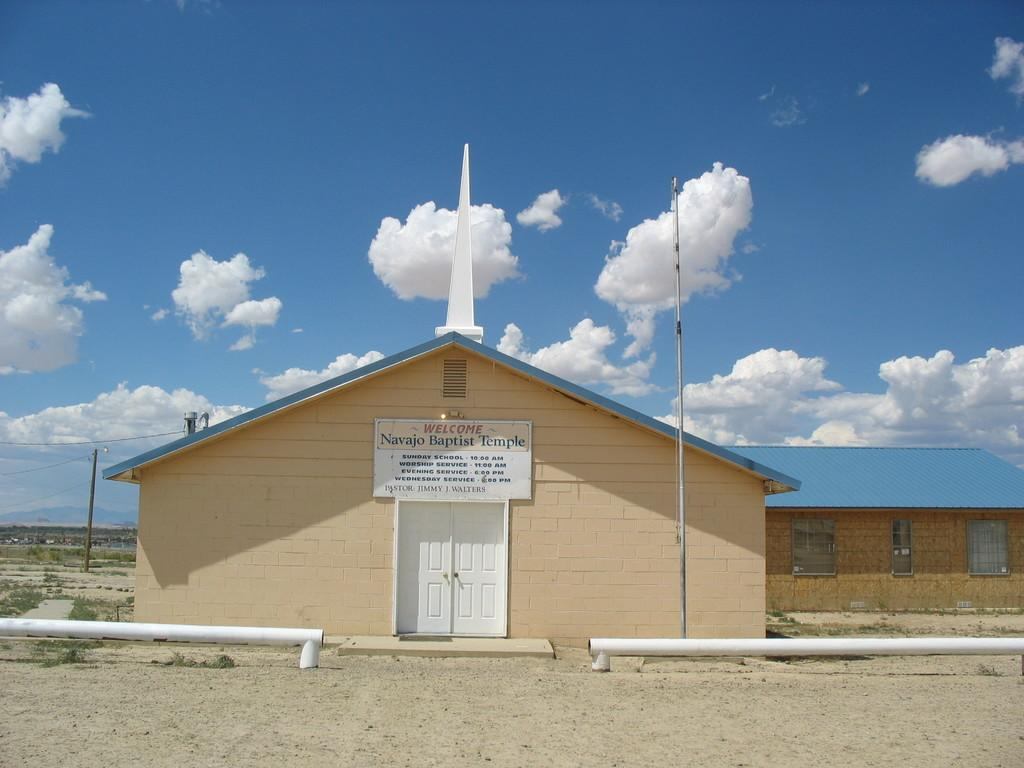What type of structure is in the picture? There is a house in the picture. What features can be seen on the house? The house has windows and doors. Is there any identification on the house? Yes, there is a name board on the house. What else can be seen in the picture besides the house? There are poles and grass present in the picture. What is visible in the background of the picture? The sky is visible in the background of the picture, and clouds are present in the sky. What type of pear is being polished on the house in the image? There is no pear or polishing activity present in the image. 